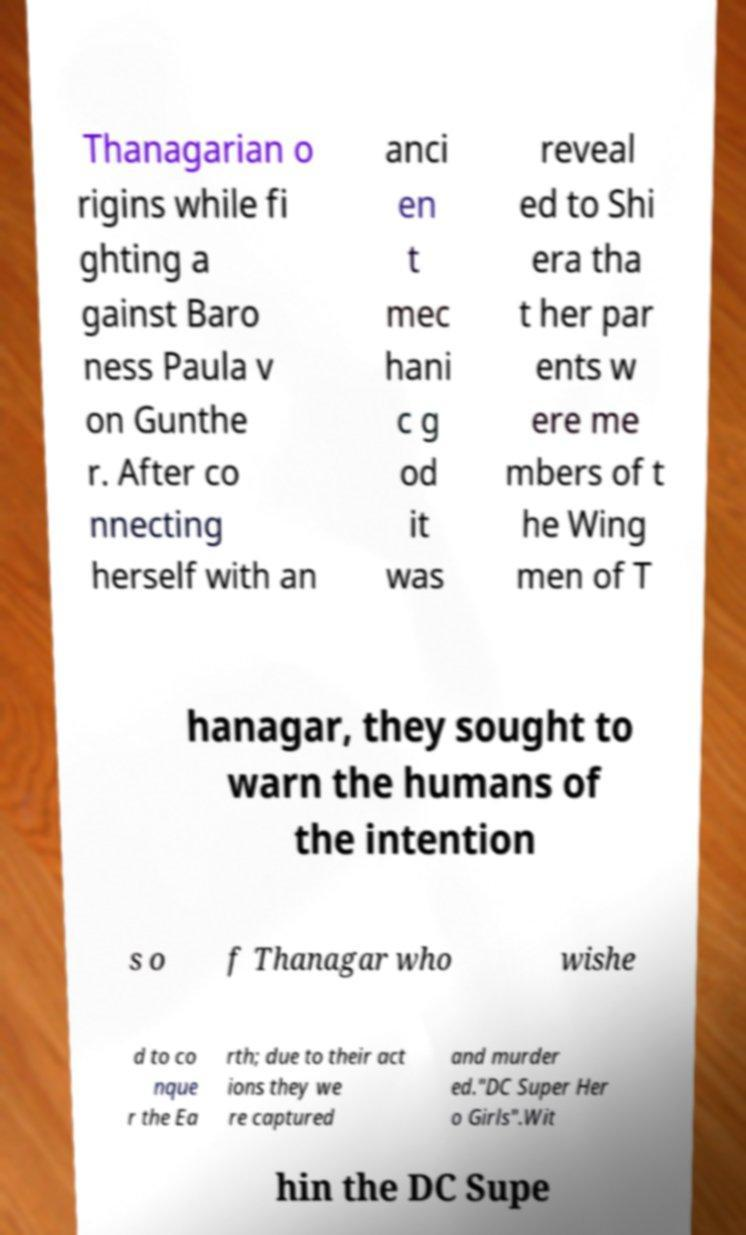Please identify and transcribe the text found in this image. Thanagarian o rigins while fi ghting a gainst Baro ness Paula v on Gunthe r. After co nnecting herself with an anci en t mec hani c g od it was reveal ed to Shi era tha t her par ents w ere me mbers of t he Wing men of T hanagar, they sought to warn the humans of the intention s o f Thanagar who wishe d to co nque r the Ea rth; due to their act ions they we re captured and murder ed."DC Super Her o Girls".Wit hin the DC Supe 